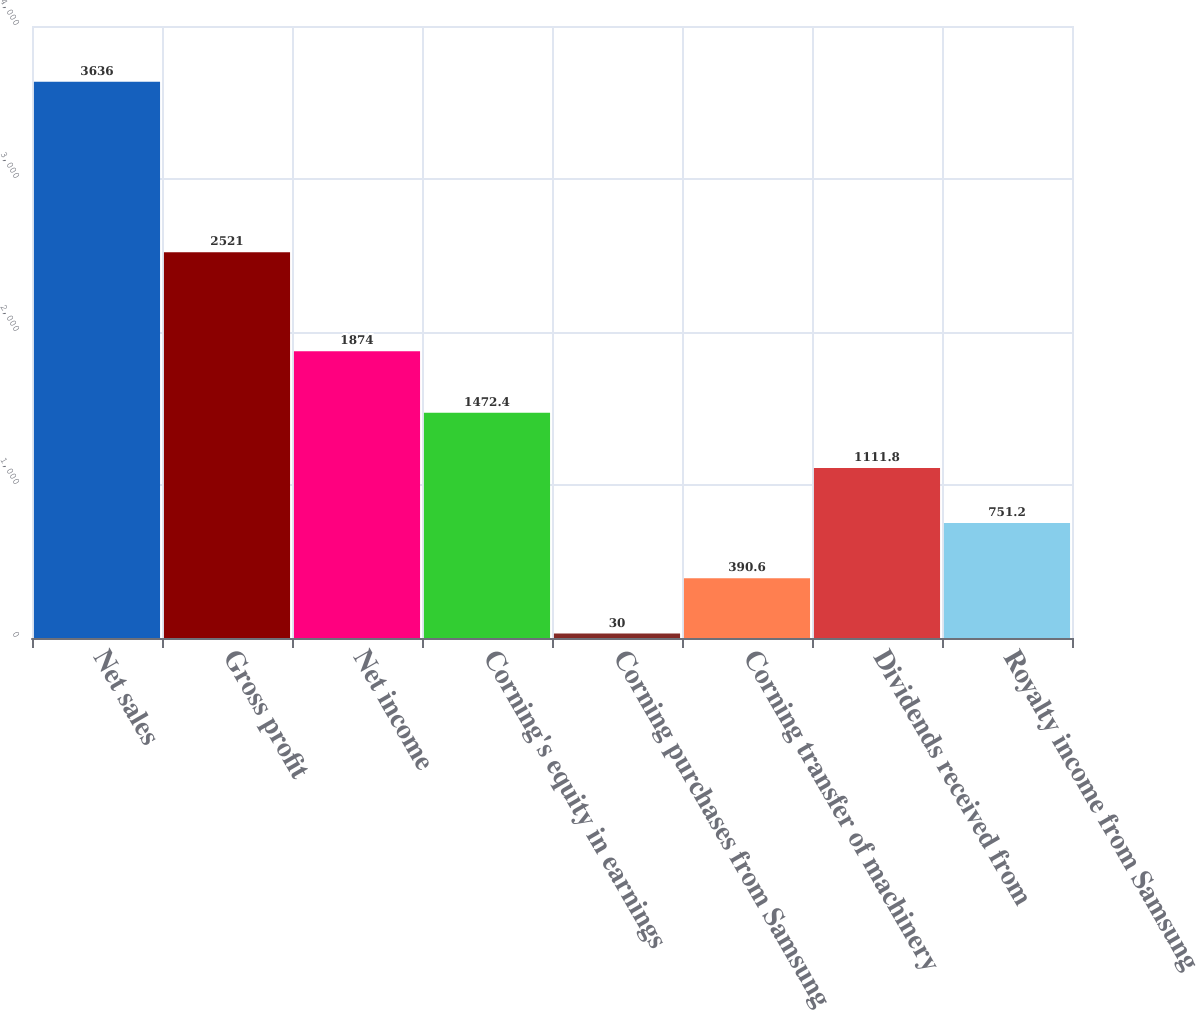<chart> <loc_0><loc_0><loc_500><loc_500><bar_chart><fcel>Net sales<fcel>Gross profit<fcel>Net income<fcel>Corning's equity in earnings<fcel>Corning purchases from Samsung<fcel>Corning transfer of machinery<fcel>Dividends received from<fcel>Royalty income from Samsung<nl><fcel>3636<fcel>2521<fcel>1874<fcel>1472.4<fcel>30<fcel>390.6<fcel>1111.8<fcel>751.2<nl></chart> 